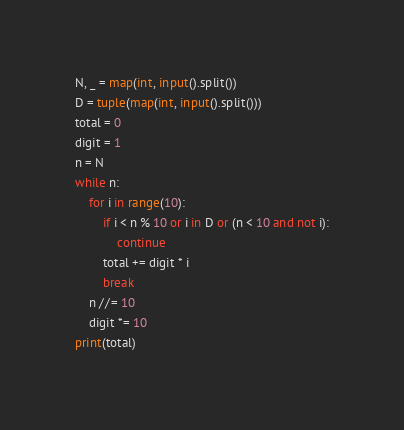Convert code to text. <code><loc_0><loc_0><loc_500><loc_500><_Python_>N, _ = map(int, input().split())
D = tuple(map(int, input().split()))
total = 0
digit = 1
n = N
while n:
    for i in range(10):
        if i < n % 10 or i in D or (n < 10 and not i):
            continue
        total += digit * i
        break
    n //= 10
    digit *= 10
print(total)</code> 